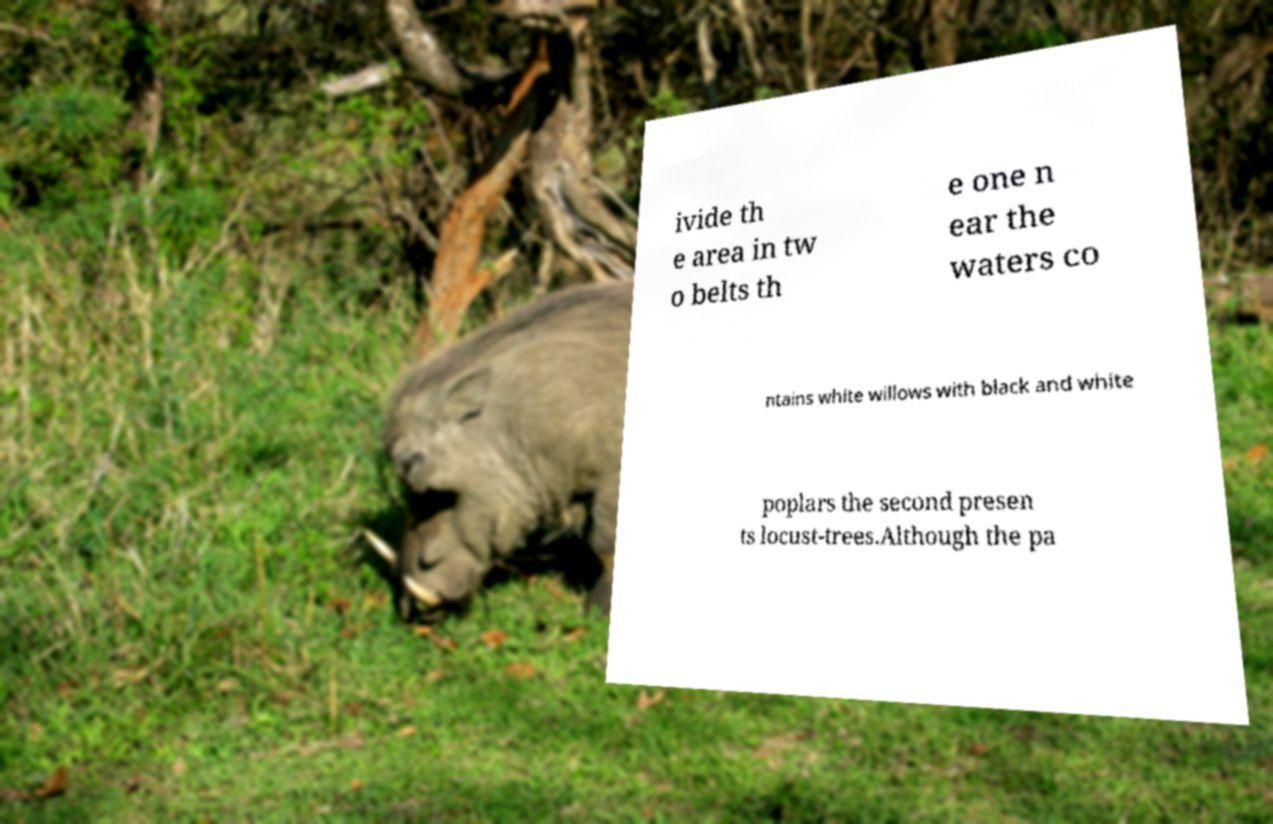Can you read and provide the text displayed in the image?This photo seems to have some interesting text. Can you extract and type it out for me? ivide th e area in tw o belts th e one n ear the waters co ntains white willows with black and white poplars the second presen ts locust-trees.Although the pa 